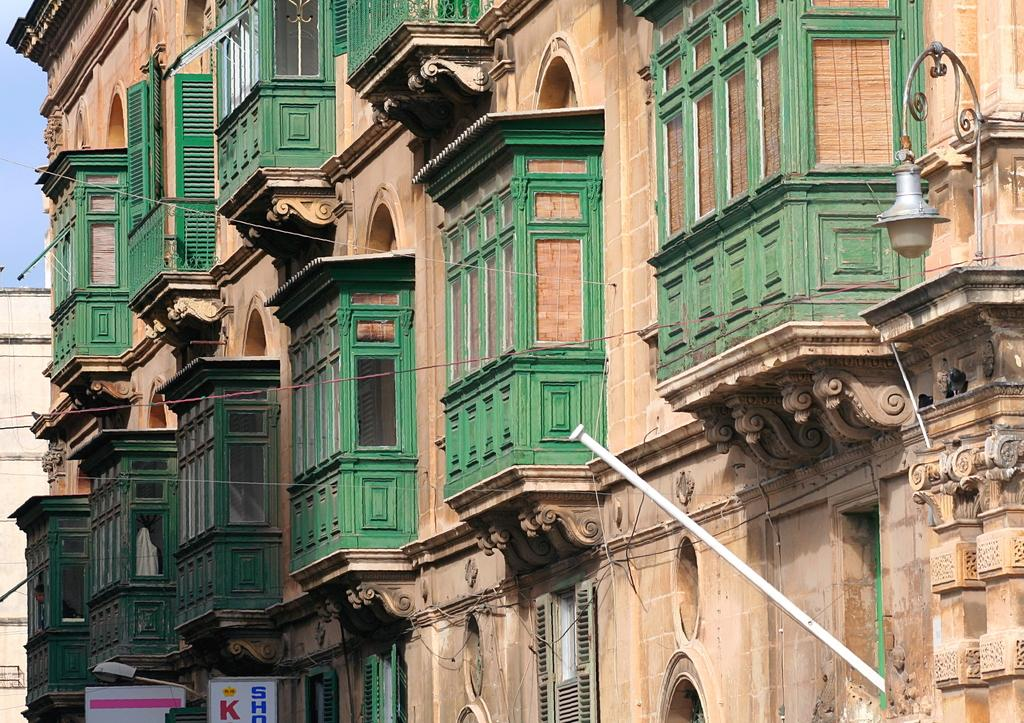What can be seen running through the image? There are wires in the image. What is located on the right side of the image? There is a lamp on the right side of the image. What type of structure is visible in the image? There is a building in the image. What color are the windows of the building? The windows of the building are green. What is present at the bottom of the building? There are boards at the bottom of the building. What type of pest can be seen crawling on the lamp in the image? There are no pests visible in the image, and the lamp is not being crawled on. What kind of picture is hanging on the wall next to the building? There is no picture hanging on the wall next to the building in the image. 